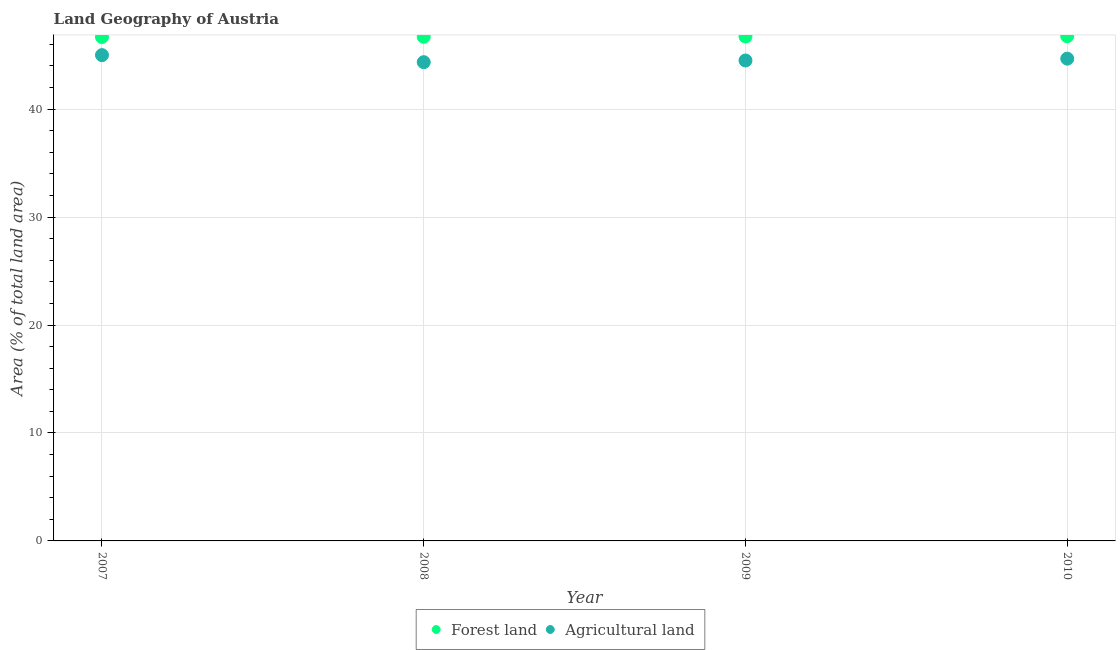How many different coloured dotlines are there?
Give a very brief answer. 2. Is the number of dotlines equal to the number of legend labels?
Provide a succinct answer. Yes. What is the percentage of land area under agriculture in 2010?
Make the answer very short. 44.67. Across all years, what is the maximum percentage of land area under forests?
Make the answer very short. 46.75. Across all years, what is the minimum percentage of land area under agriculture?
Provide a short and direct response. 44.34. In which year was the percentage of land area under forests minimum?
Your response must be concise. 2007. What is the total percentage of land area under forests in the graph?
Offer a very short reply. 186.86. What is the difference between the percentage of land area under forests in 2007 and that in 2008?
Keep it short and to the point. -0.02. What is the difference between the percentage of land area under forests in 2007 and the percentage of land area under agriculture in 2009?
Provide a succinct answer. 2.18. What is the average percentage of land area under forests per year?
Provide a succinct answer. 46.71. In the year 2008, what is the difference between the percentage of land area under agriculture and percentage of land area under forests?
Give a very brief answer. -2.36. What is the ratio of the percentage of land area under forests in 2008 to that in 2009?
Ensure brevity in your answer.  1. Is the percentage of land area under agriculture in 2008 less than that in 2009?
Offer a very short reply. Yes. Is the difference between the percentage of land area under forests in 2009 and 2010 greater than the difference between the percentage of land area under agriculture in 2009 and 2010?
Provide a succinct answer. Yes. What is the difference between the highest and the second highest percentage of land area under agriculture?
Give a very brief answer. 0.33. What is the difference between the highest and the lowest percentage of land area under agriculture?
Provide a short and direct response. 0.65. In how many years, is the percentage of land area under forests greater than the average percentage of land area under forests taken over all years?
Offer a very short reply. 2. Is the sum of the percentage of land area under forests in 2007 and 2009 greater than the maximum percentage of land area under agriculture across all years?
Make the answer very short. Yes. Are the values on the major ticks of Y-axis written in scientific E-notation?
Your answer should be compact. No. Does the graph contain any zero values?
Offer a terse response. No. Does the graph contain grids?
Keep it short and to the point. Yes. Where does the legend appear in the graph?
Provide a short and direct response. Bottom center. What is the title of the graph?
Keep it short and to the point. Land Geography of Austria. What is the label or title of the X-axis?
Your response must be concise. Year. What is the label or title of the Y-axis?
Offer a terse response. Area (% of total land area). What is the Area (% of total land area) of Forest land in 2007?
Give a very brief answer. 46.68. What is the Area (% of total land area) of Agricultural land in 2007?
Your answer should be compact. 45. What is the Area (% of total land area) of Forest land in 2008?
Provide a short and direct response. 46.7. What is the Area (% of total land area) in Agricultural land in 2008?
Offer a terse response. 44.34. What is the Area (% of total land area) in Forest land in 2009?
Give a very brief answer. 46.73. What is the Area (% of total land area) of Agricultural land in 2009?
Give a very brief answer. 44.5. What is the Area (% of total land area) in Forest land in 2010?
Keep it short and to the point. 46.75. What is the Area (% of total land area) in Agricultural land in 2010?
Give a very brief answer. 44.67. Across all years, what is the maximum Area (% of total land area) in Forest land?
Offer a very short reply. 46.75. Across all years, what is the maximum Area (% of total land area) in Agricultural land?
Make the answer very short. 45. Across all years, what is the minimum Area (% of total land area) of Forest land?
Make the answer very short. 46.68. Across all years, what is the minimum Area (% of total land area) of Agricultural land?
Give a very brief answer. 44.34. What is the total Area (% of total land area) in Forest land in the graph?
Give a very brief answer. 186.86. What is the total Area (% of total land area) in Agricultural land in the graph?
Your answer should be compact. 178.52. What is the difference between the Area (% of total land area) of Forest land in 2007 and that in 2008?
Offer a terse response. -0.02. What is the difference between the Area (% of total land area) in Agricultural land in 2007 and that in 2008?
Your answer should be compact. 0.65. What is the difference between the Area (% of total land area) of Forest land in 2007 and that in 2009?
Make the answer very short. -0.05. What is the difference between the Area (% of total land area) of Agricultural land in 2007 and that in 2009?
Ensure brevity in your answer.  0.5. What is the difference between the Area (% of total land area) of Forest land in 2007 and that in 2010?
Give a very brief answer. -0.07. What is the difference between the Area (% of total land area) in Agricultural land in 2007 and that in 2010?
Provide a short and direct response. 0.33. What is the difference between the Area (% of total land area) in Forest land in 2008 and that in 2009?
Provide a short and direct response. -0.03. What is the difference between the Area (% of total land area) in Agricultural land in 2008 and that in 2009?
Provide a short and direct response. -0.16. What is the difference between the Area (% of total land area) in Forest land in 2008 and that in 2010?
Offer a terse response. -0.05. What is the difference between the Area (% of total land area) of Agricultural land in 2008 and that in 2010?
Ensure brevity in your answer.  -0.33. What is the difference between the Area (% of total land area) in Forest land in 2009 and that in 2010?
Keep it short and to the point. -0.03. What is the difference between the Area (% of total land area) in Agricultural land in 2009 and that in 2010?
Provide a succinct answer. -0.17. What is the difference between the Area (% of total land area) in Forest land in 2007 and the Area (% of total land area) in Agricultural land in 2008?
Provide a succinct answer. 2.33. What is the difference between the Area (% of total land area) in Forest land in 2007 and the Area (% of total land area) in Agricultural land in 2009?
Keep it short and to the point. 2.18. What is the difference between the Area (% of total land area) of Forest land in 2007 and the Area (% of total land area) of Agricultural land in 2010?
Keep it short and to the point. 2.01. What is the difference between the Area (% of total land area) in Forest land in 2008 and the Area (% of total land area) in Agricultural land in 2009?
Make the answer very short. 2.2. What is the difference between the Area (% of total land area) in Forest land in 2008 and the Area (% of total land area) in Agricultural land in 2010?
Your response must be concise. 2.03. What is the difference between the Area (% of total land area) of Forest land in 2009 and the Area (% of total land area) of Agricultural land in 2010?
Your answer should be very brief. 2.05. What is the average Area (% of total land area) in Forest land per year?
Your response must be concise. 46.71. What is the average Area (% of total land area) in Agricultural land per year?
Offer a very short reply. 44.63. In the year 2007, what is the difference between the Area (% of total land area) of Forest land and Area (% of total land area) of Agricultural land?
Provide a short and direct response. 1.68. In the year 2008, what is the difference between the Area (% of total land area) of Forest land and Area (% of total land area) of Agricultural land?
Give a very brief answer. 2.36. In the year 2009, what is the difference between the Area (% of total land area) in Forest land and Area (% of total land area) in Agricultural land?
Your answer should be compact. 2.22. In the year 2010, what is the difference between the Area (% of total land area) of Forest land and Area (% of total land area) of Agricultural land?
Provide a succinct answer. 2.08. What is the ratio of the Area (% of total land area) in Forest land in 2007 to that in 2008?
Offer a very short reply. 1. What is the ratio of the Area (% of total land area) in Agricultural land in 2007 to that in 2008?
Offer a terse response. 1.01. What is the ratio of the Area (% of total land area) in Agricultural land in 2007 to that in 2009?
Give a very brief answer. 1.01. What is the ratio of the Area (% of total land area) of Forest land in 2007 to that in 2010?
Keep it short and to the point. 1. What is the ratio of the Area (% of total land area) of Agricultural land in 2007 to that in 2010?
Provide a short and direct response. 1.01. What is the ratio of the Area (% of total land area) of Agricultural land in 2008 to that in 2009?
Offer a terse response. 1. What is the ratio of the Area (% of total land area) of Agricultural land in 2008 to that in 2010?
Provide a short and direct response. 0.99. What is the ratio of the Area (% of total land area) in Forest land in 2009 to that in 2010?
Give a very brief answer. 1. What is the ratio of the Area (% of total land area) of Agricultural land in 2009 to that in 2010?
Your answer should be very brief. 1. What is the difference between the highest and the second highest Area (% of total land area) in Forest land?
Your answer should be compact. 0.03. What is the difference between the highest and the second highest Area (% of total land area) of Agricultural land?
Offer a terse response. 0.33. What is the difference between the highest and the lowest Area (% of total land area) in Forest land?
Keep it short and to the point. 0.07. What is the difference between the highest and the lowest Area (% of total land area) of Agricultural land?
Offer a very short reply. 0.65. 